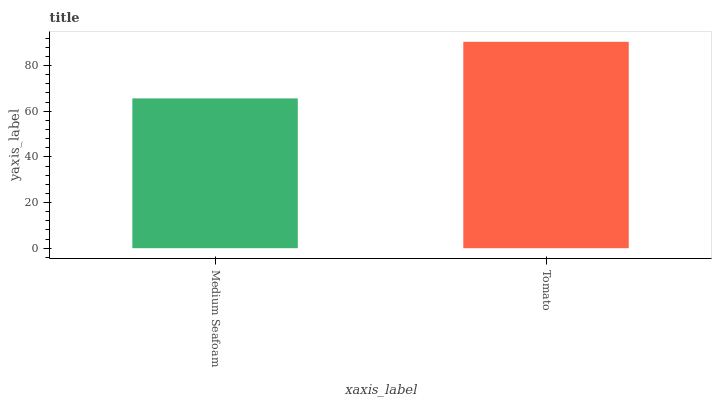Is Medium Seafoam the minimum?
Answer yes or no. Yes. Is Tomato the maximum?
Answer yes or no. Yes. Is Tomato the minimum?
Answer yes or no. No. Is Tomato greater than Medium Seafoam?
Answer yes or no. Yes. Is Medium Seafoam less than Tomato?
Answer yes or no. Yes. Is Medium Seafoam greater than Tomato?
Answer yes or no. No. Is Tomato less than Medium Seafoam?
Answer yes or no. No. Is Tomato the high median?
Answer yes or no. Yes. Is Medium Seafoam the low median?
Answer yes or no. Yes. Is Medium Seafoam the high median?
Answer yes or no. No. Is Tomato the low median?
Answer yes or no. No. 